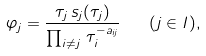<formula> <loc_0><loc_0><loc_500><loc_500>\varphi _ { j } = \frac { \tau _ { j } \, s _ { j } ( \tau _ { j } ) } { \prod _ { i \ne j } \, \tau _ { i } ^ { - a _ { i j } } } \quad ( j \in I ) ,</formula> 